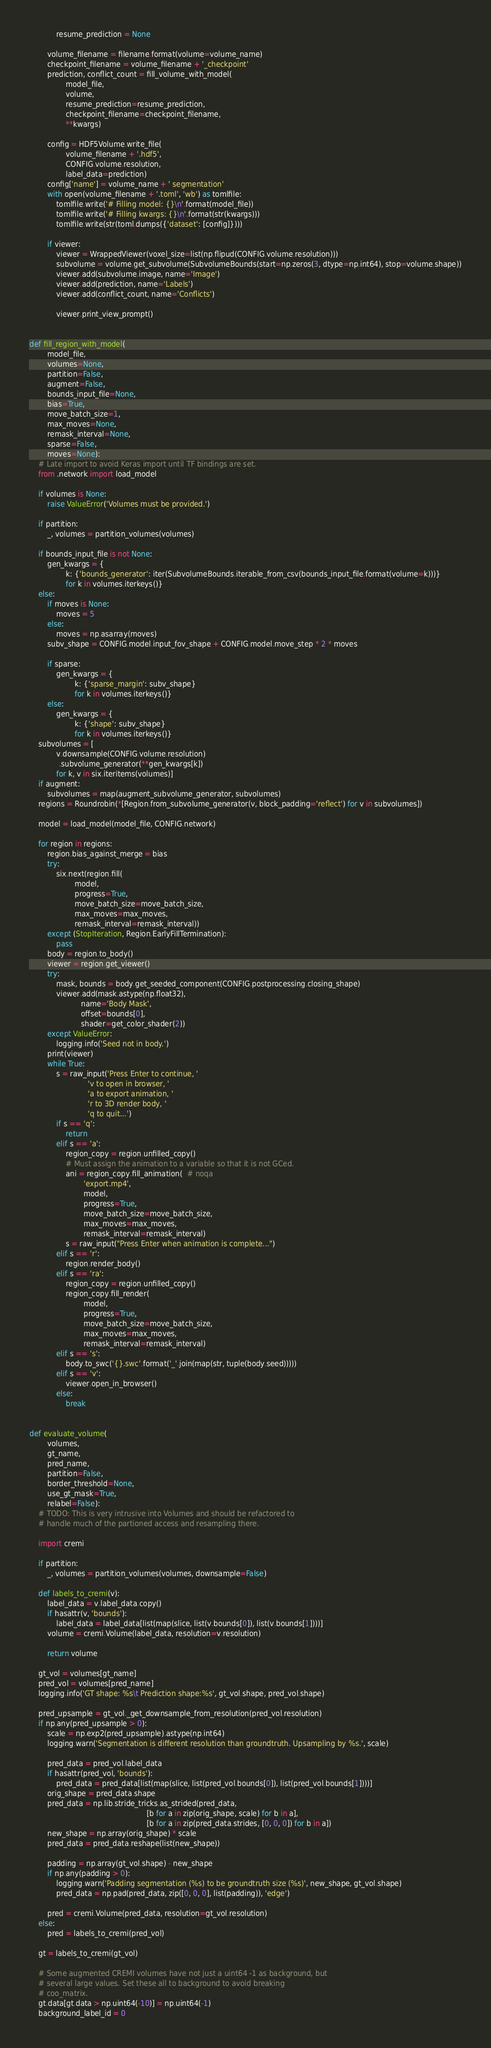Convert code to text. <code><loc_0><loc_0><loc_500><loc_500><_Python_>            resume_prediction = None

        volume_filename = filename.format(volume=volume_name)
        checkpoint_filename = volume_filename + '_checkpoint'
        prediction, conflict_count = fill_volume_with_model(
                model_file,
                volume,
                resume_prediction=resume_prediction,
                checkpoint_filename=checkpoint_filename,
                **kwargs)

        config = HDF5Volume.write_file(
                volume_filename + '.hdf5',
                CONFIG.volume.resolution,
                label_data=prediction)
        config['name'] = volume_name + ' segmentation'
        with open(volume_filename + '.toml', 'wb') as tomlfile:
            tomlfile.write('# Filling model: {}\n'.format(model_file))
            tomlfile.write('# Filling kwargs: {}\n'.format(str(kwargs)))
            tomlfile.write(str(toml.dumps({'dataset': [config]})))

        if viewer:
            viewer = WrappedViewer(voxel_size=list(np.flipud(CONFIG.volume.resolution)))
            subvolume = volume.get_subvolume(SubvolumeBounds(start=np.zeros(3, dtype=np.int64), stop=volume.shape))
            viewer.add(subvolume.image, name='Image')
            viewer.add(prediction, name='Labels')
            viewer.add(conflict_count, name='Conflicts')

            viewer.print_view_prompt()


def fill_region_with_model(
        model_file,
        volumes=None,
        partition=False,
        augment=False,
        bounds_input_file=None,
        bias=True,
        move_batch_size=1,
        max_moves=None,
        remask_interval=None,
        sparse=False,
        moves=None):
    # Late import to avoid Keras import until TF bindings are set.
    from .network import load_model

    if volumes is None:
        raise ValueError('Volumes must be provided.')

    if partition:
        _, volumes = partition_volumes(volumes)

    if bounds_input_file is not None:
        gen_kwargs = {
                k: {'bounds_generator': iter(SubvolumeBounds.iterable_from_csv(bounds_input_file.format(volume=k)))}
                for k in volumes.iterkeys()}
    else:
        if moves is None:
            moves = 5
        else:
            moves = np.asarray(moves)
        subv_shape = CONFIG.model.input_fov_shape + CONFIG.model.move_step * 2 * moves

        if sparse:
            gen_kwargs = {
                    k: {'sparse_margin': subv_shape}
                    for k in volumes.iterkeys()}
        else:
            gen_kwargs = {
                    k: {'shape': subv_shape}
                    for k in volumes.iterkeys()}
    subvolumes = [
            v.downsample(CONFIG.volume.resolution)
             .subvolume_generator(**gen_kwargs[k])
            for k, v in six.iteritems(volumes)]
    if augment:
        subvolumes = map(augment_subvolume_generator, subvolumes)
    regions = Roundrobin(*[Region.from_subvolume_generator(v, block_padding='reflect') for v in subvolumes])

    model = load_model(model_file, CONFIG.network)

    for region in regions:
        region.bias_against_merge = bias
        try:
            six.next(region.fill(
                    model,
                    progress=True,
                    move_batch_size=move_batch_size,
                    max_moves=max_moves,
                    remask_interval=remask_interval))
        except (StopIteration, Region.EarlyFillTermination):
            pass
        body = region.to_body()
        viewer = region.get_viewer()
        try:
            mask, bounds = body.get_seeded_component(CONFIG.postprocessing.closing_shape)
            viewer.add(mask.astype(np.float32),
                       name='Body Mask',
                       offset=bounds[0],
                       shader=get_color_shader(2))
        except ValueError:
            logging.info('Seed not in body.')
        print(viewer)
        while True:
            s = raw_input('Press Enter to continue, '
                          'v to open in browser, '
                          'a to export animation, '
                          'r to 3D render body, '
                          'q to quit...')
            if s == 'q':
                return
            elif s == 'a':
                region_copy = region.unfilled_copy()
                # Must assign the animation to a variable so that it is not GCed.
                ani = region_copy.fill_animation(  # noqa
                        'export.mp4',
                        model,
                        progress=True,
                        move_batch_size=move_batch_size,
                        max_moves=max_moves,
                        remask_interval=remask_interval)
                s = raw_input("Press Enter when animation is complete...")
            elif s == 'r':
                region.render_body()
            elif s == 'ra':
                region_copy = region.unfilled_copy()
                region_copy.fill_render(
                        model,
                        progress=True,
                        move_batch_size=move_batch_size,
                        max_moves=max_moves,
                        remask_interval=remask_interval)
            elif s == 's':
                body.to_swc('{}.swc'.format('_'.join(map(str, tuple(body.seed)))))
            elif s == 'v':
                viewer.open_in_browser()
            else:
                break


def evaluate_volume(
        volumes,
        gt_name,
        pred_name,
        partition=False,
        border_threshold=None,
        use_gt_mask=True,
        relabel=False):
    # TODO: This is very intrusive into Volumes and should be refactored to
    # handle much of the partioned access and resampling there.

    import cremi

    if partition:
        _, volumes = partition_volumes(volumes, downsample=False)

    def labels_to_cremi(v):
        label_data = v.label_data.copy()
        if hasattr(v, 'bounds'):
            label_data = label_data[list(map(slice, list(v.bounds[0]), list(v.bounds[1])))]
        volume = cremi.Volume(label_data, resolution=v.resolution)

        return volume

    gt_vol = volumes[gt_name]
    pred_vol = volumes[pred_name]
    logging.info('GT shape: %s\t Prediction shape:%s', gt_vol.shape, pred_vol.shape)

    pred_upsample = gt_vol._get_downsample_from_resolution(pred_vol.resolution)
    if np.any(pred_upsample > 0):
        scale = np.exp2(pred_upsample).astype(np.int64)
        logging.warn('Segmentation is different resolution than groundtruth. Upsampling by %s.', scale)

        pred_data = pred_vol.label_data
        if hasattr(pred_vol, 'bounds'):
            pred_data = pred_data[list(map(slice, list(pred_vol.bounds[0]), list(pred_vol.bounds[1])))]
        orig_shape = pred_data.shape
        pred_data = np.lib.stride_tricks.as_strided(pred_data,
                                                    [b for a in zip(orig_shape, scale) for b in a],
                                                    [b for a in zip(pred_data.strides, [0, 0, 0]) for b in a])
        new_shape = np.array(orig_shape) * scale
        pred_data = pred_data.reshape(list(new_shape))

        padding = np.array(gt_vol.shape) - new_shape
        if np.any(padding > 0):
            logging.warn('Padding segmentation (%s) to be groundtruth size (%s)', new_shape, gt_vol.shape)
            pred_data = np.pad(pred_data, zip([0, 0, 0], list(padding)), 'edge')

        pred = cremi.Volume(pred_data, resolution=gt_vol.resolution)
    else:
        pred = labels_to_cremi(pred_vol)

    gt = labels_to_cremi(gt_vol)

    # Some augmented CREMI volumes have not just a uint64 -1 as background, but
    # several large values. Set these all to background to avoid breaking
    # coo_matrix.
    gt.data[gt.data > np.uint64(-10)] = np.uint64(-1)
    background_label_id = 0</code> 